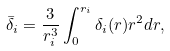Convert formula to latex. <formula><loc_0><loc_0><loc_500><loc_500>\bar { \delta } _ { i } = \frac { 3 } { r _ { i } ^ { 3 } } \int _ { 0 } ^ { r _ { i } } \delta _ { i } ( r ) r ^ { 2 } d r ,</formula> 